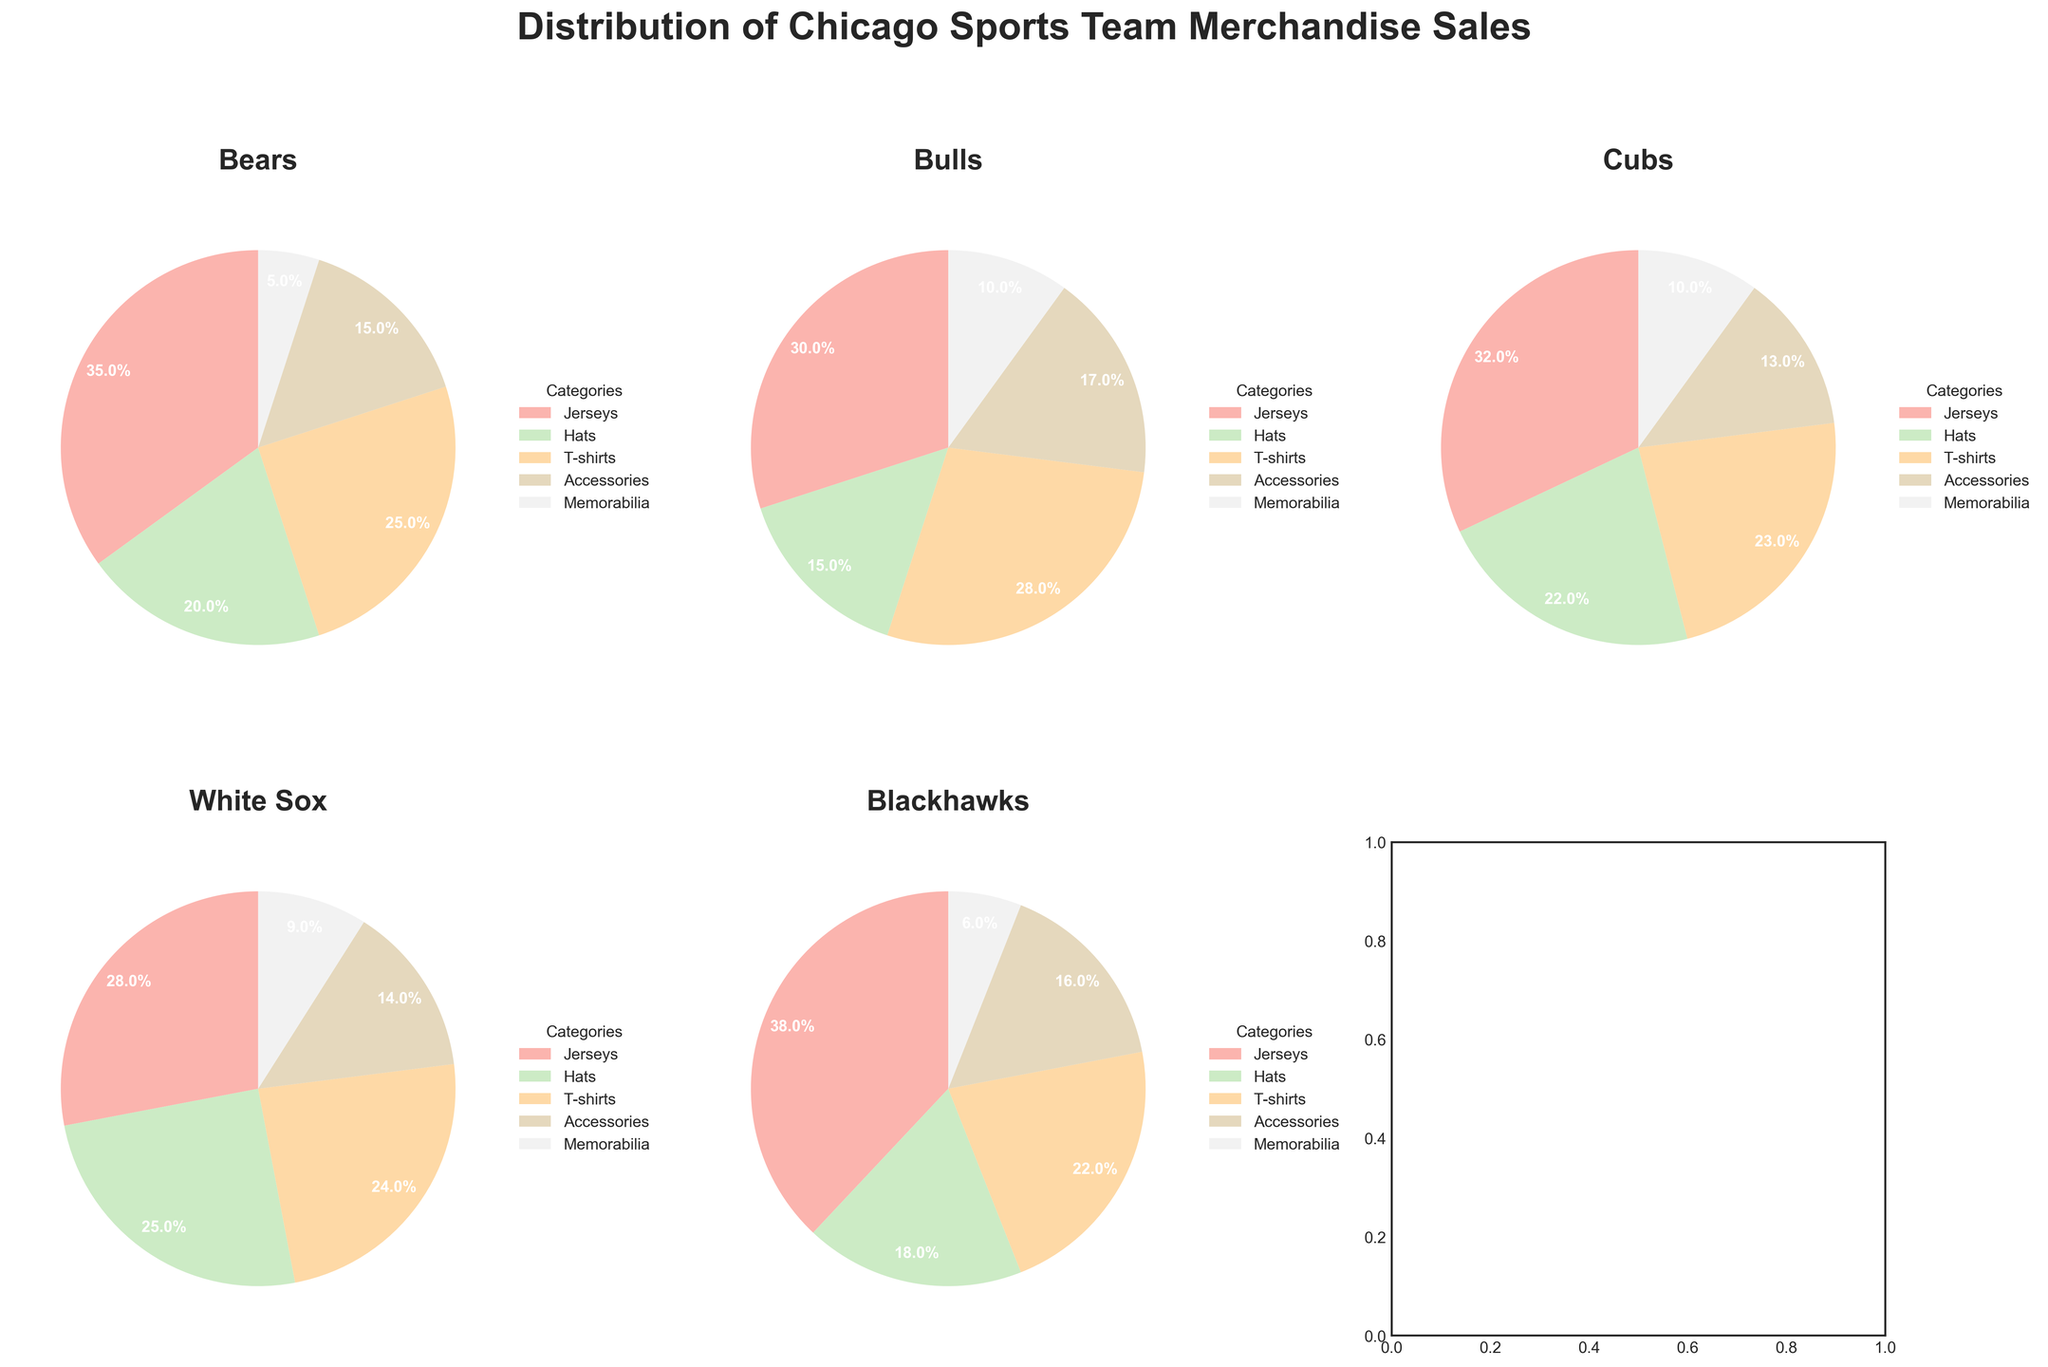Which team has the highest percentage of sales in the Jerseys category? The figure shows the percentage distribution of merchandise for each team. To find the team with the highest percentage of sales in the Jerseys category, identify the highest percentage labeled for Jerseys in each pie chart. The Bears have 35%, the Bulls have 30%, the Cubs have 32%, the White Sox have 28%, and the Blackhawks have 38%.
Answer: Blackhawks Which team sells more T-shirts, Bulls or Cubs? The figure lists percentages for T-shirts sales. Comparing the Bulls and Cubs, the Bulls have 28% and the Cubs have 23%.
Answer: Bulls What's the average percentage of sales for Accessories across all teams? To find the average percentage of Accessories sales, sum up the percentages for each team and divide by the number of teams. Bears: 15%, Bulls: 17%, Cubs: 13%, White Sox: 14%, Blackhawks: 16%. Sum: 15 + 17 + 13 + 14 + 16 = 75. Number of teams: 5. Average: 75/5 = 15%
Answer: 15% Which team has the smallest percentage of Memorabilia sales? Identify the smallest percentage for Memorabilia in each pie chart. The Bears have 5%, the Bulls have 10%, the Cubs have 10%, the White Sox have 9%, and the Blackhawks have 6%.
Answer: Bears How does the percentage of Hats sales for the White Sox compare to Hats sales for the Bears? The figure provides percentages for Hats sales. The White Sox have 25% and the Bears have 20%. The White Sox have a higher percentage.
Answer: White Sox Sum the percentages of Jerseys and Hats sales for the Bulls. To find the total percentage of Jerseys and Hats sales for the Bulls, add the percentages for these categories. Jerseys: 30%, Hats: 15%. Sum: 30 + 15 = 45%
Answer: 45% Which category has a uniform percentage of sales across all teams? Examine each category to see if any has the same percentage across all teams. No category has a uniform percentage value across all teams.
Answer: None What percentage of sales does Memorabilia represent for the Cubs relative to the category's total sales across all teams? First, find the total percentage of Memorabilia sales across all teams by summing individual values. Bears: 5%, Bulls: 10%, Cubs: 10%, White Sox: 9%, Blackhawks: 6%. Total: 40%. Cubs' percentage is 10%. Ratio of Cubs' memorabilia sales to total memorabilia sales: (10/40)*100 = 25%.
Answer: 25% Which team has the most balanced distribution of merchandise sales across all categories? For the most balanced distribution, check which team's segments in the pie chart are most similar in size. The Bears and White Sox have closer percentages across categories, but the White Sox appear more balanced graphically.
Answer: White Sox 